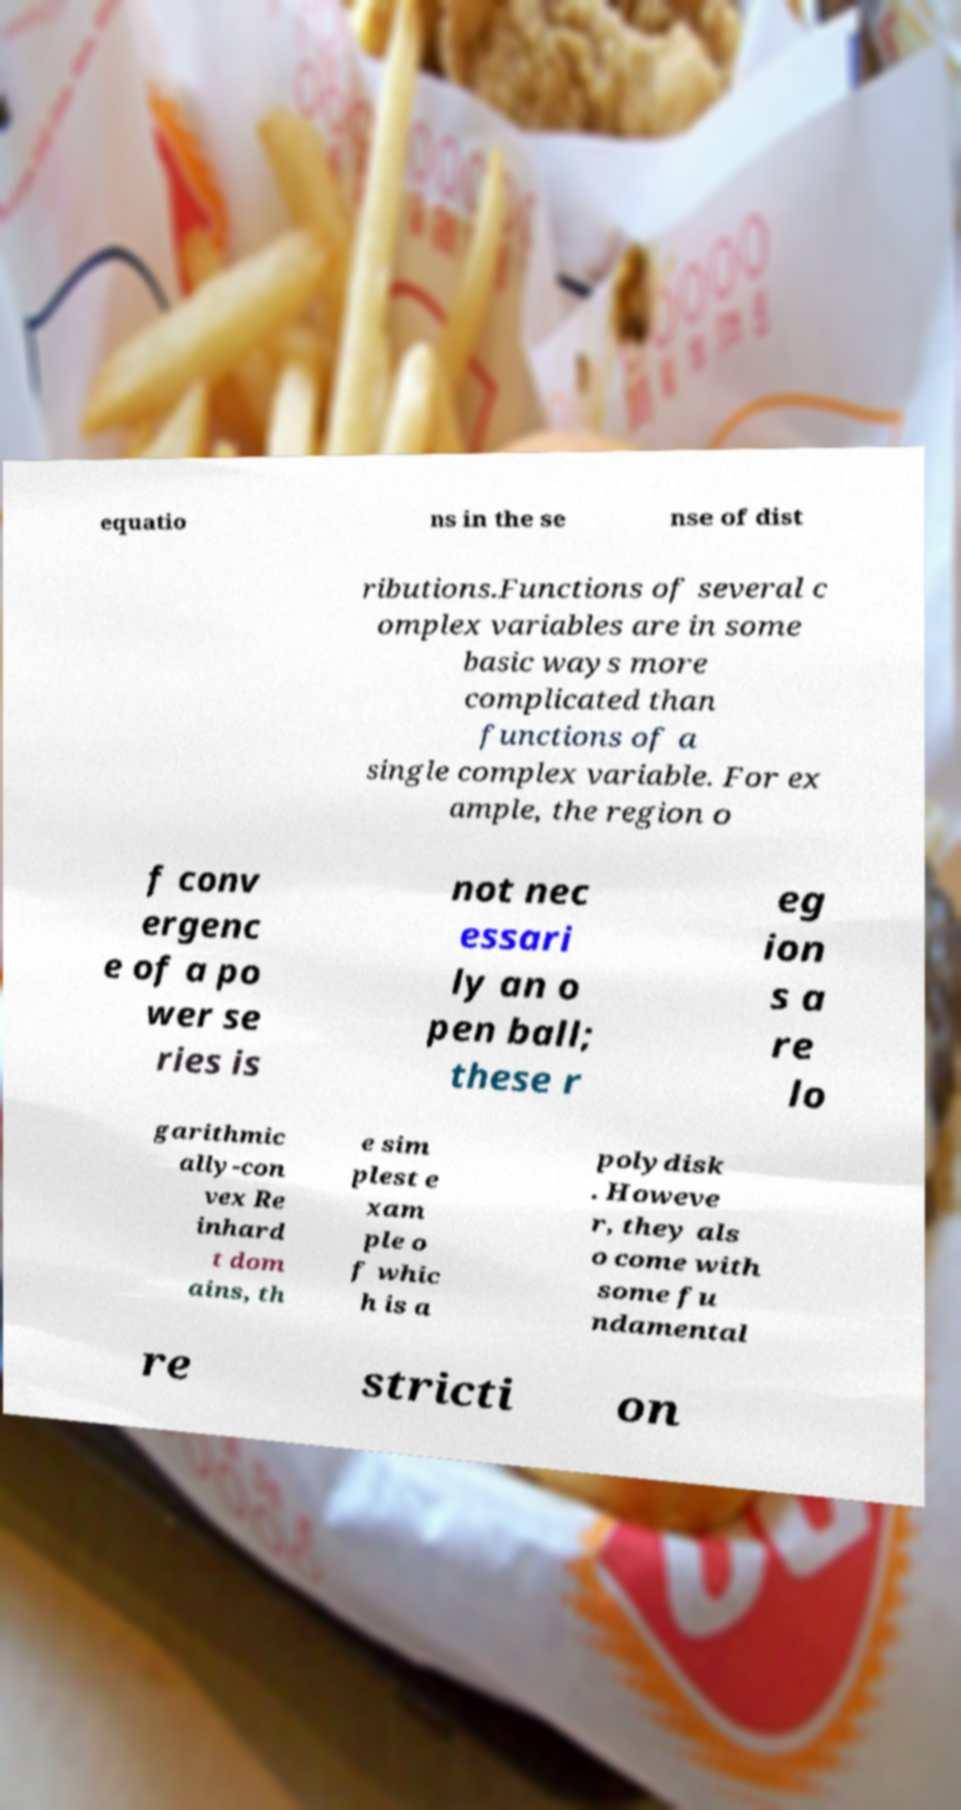Please read and relay the text visible in this image. What does it say? equatio ns in the se nse of dist ributions.Functions of several c omplex variables are in some basic ways more complicated than functions of a single complex variable. For ex ample, the region o f conv ergenc e of a po wer se ries is not nec essari ly an o pen ball; these r eg ion s a re lo garithmic ally-con vex Re inhard t dom ains, th e sim plest e xam ple o f whic h is a polydisk . Howeve r, they als o come with some fu ndamental re stricti on 